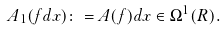Convert formula to latex. <formula><loc_0><loc_0><loc_500><loc_500>A _ { 1 } ( f d x ) \colon = A ( f ) d x \in \Omega ^ { 1 } ( { R } ) .</formula> 